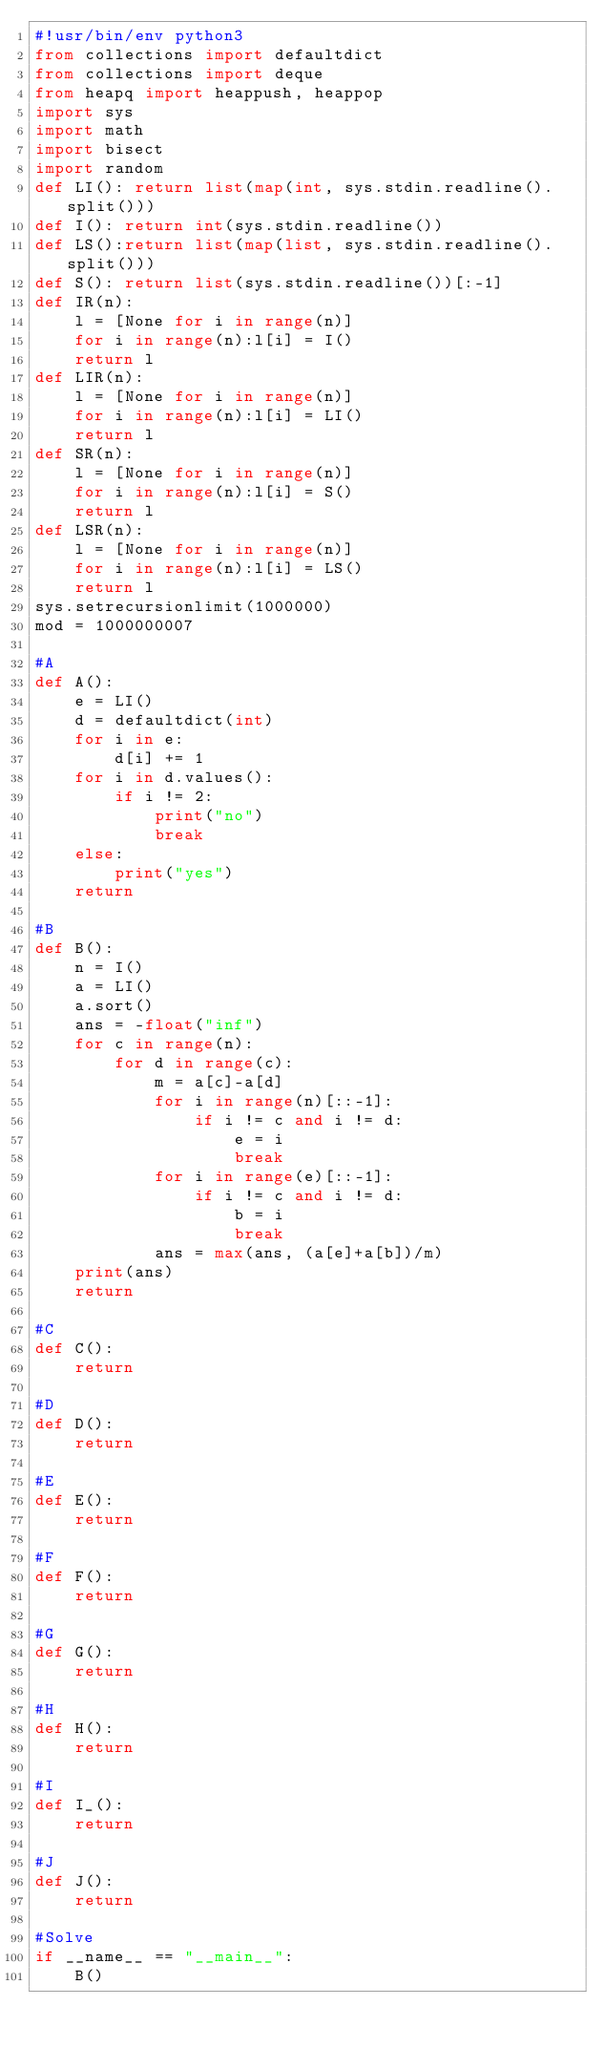<code> <loc_0><loc_0><loc_500><loc_500><_Python_>#!usr/bin/env python3
from collections import defaultdict
from collections import deque
from heapq import heappush, heappop
import sys
import math
import bisect
import random
def LI(): return list(map(int, sys.stdin.readline().split()))
def I(): return int(sys.stdin.readline())
def LS():return list(map(list, sys.stdin.readline().split()))
def S(): return list(sys.stdin.readline())[:-1]
def IR(n):
    l = [None for i in range(n)]
    for i in range(n):l[i] = I()
    return l
def LIR(n):
    l = [None for i in range(n)]
    for i in range(n):l[i] = LI()
    return l
def SR(n):
    l = [None for i in range(n)]
    for i in range(n):l[i] = S()
    return l
def LSR(n):
    l = [None for i in range(n)]
    for i in range(n):l[i] = LS()
    return l
sys.setrecursionlimit(1000000)
mod = 1000000007

#A
def A():
    e = LI()
    d = defaultdict(int)
    for i in e:
        d[i] += 1
    for i in d.values():
        if i != 2:
            print("no")
            break
    else:
        print("yes")
    return

#B
def B():
    n = I()
    a = LI()
    a.sort()
    ans = -float("inf")
    for c in range(n):
        for d in range(c):
            m = a[c]-a[d]
            for i in range(n)[::-1]:
                if i != c and i != d:
                    e = i
                    break
            for i in range(e)[::-1]:
                if i != c and i != d:
                    b = i
                    break
            ans = max(ans, (a[e]+a[b])/m)
    print(ans)
    return

#C
def C():
    return

#D
def D():
    return

#E
def E():
    return

#F
def F():
    return

#G
def G():
    return

#H
def H():
    return

#I
def I_():
    return

#J
def J():
    return

#Solve
if __name__ == "__main__":
    B()

</code> 